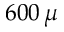Convert formula to latex. <formula><loc_0><loc_0><loc_500><loc_500>6 0 0 \, \mu</formula> 